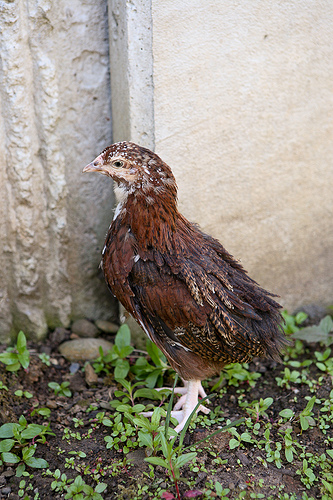<image>
Is the bird to the left of the wall? No. The bird is not to the left of the wall. From this viewpoint, they have a different horizontal relationship. 